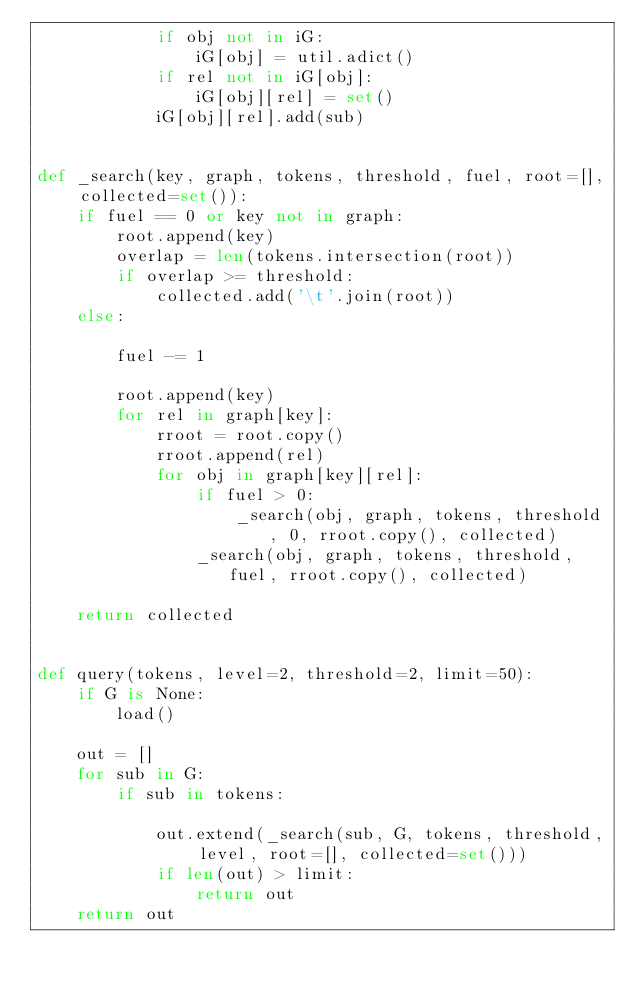<code> <loc_0><loc_0><loc_500><loc_500><_Python_>			if obj not in iG:
				iG[obj] = util.adict()
			if rel not in iG[obj]:
				iG[obj][rel] = set()
			iG[obj][rel].add(sub)


def _search(key, graph, tokens, threshold, fuel, root=[], collected=set()):
	if fuel == 0 or key not in graph:
		root.append(key)
		overlap = len(tokens.intersection(root))
		if overlap >= threshold:
			collected.add('\t'.join(root))
	else:
		
		fuel -= 1
		
		root.append(key)
		for rel in graph[key]:
			rroot = root.copy()
			rroot.append(rel)
			for obj in graph[key][rel]:
				if fuel > 0:
					_search(obj, graph, tokens, threshold, 0, rroot.copy(), collected)
				_search(obj, graph, tokens, threshold, fuel, rroot.copy(), collected)
	
	return collected


def query(tokens, level=2, threshold=2, limit=50):
	if G is None:
		load()
	
	out = []
	for sub in G:
		if sub in tokens:
			
			out.extend(_search(sub, G, tokens, threshold, level, root=[], collected=set()))
			if len(out) > limit:
				return out
	return out








</code> 